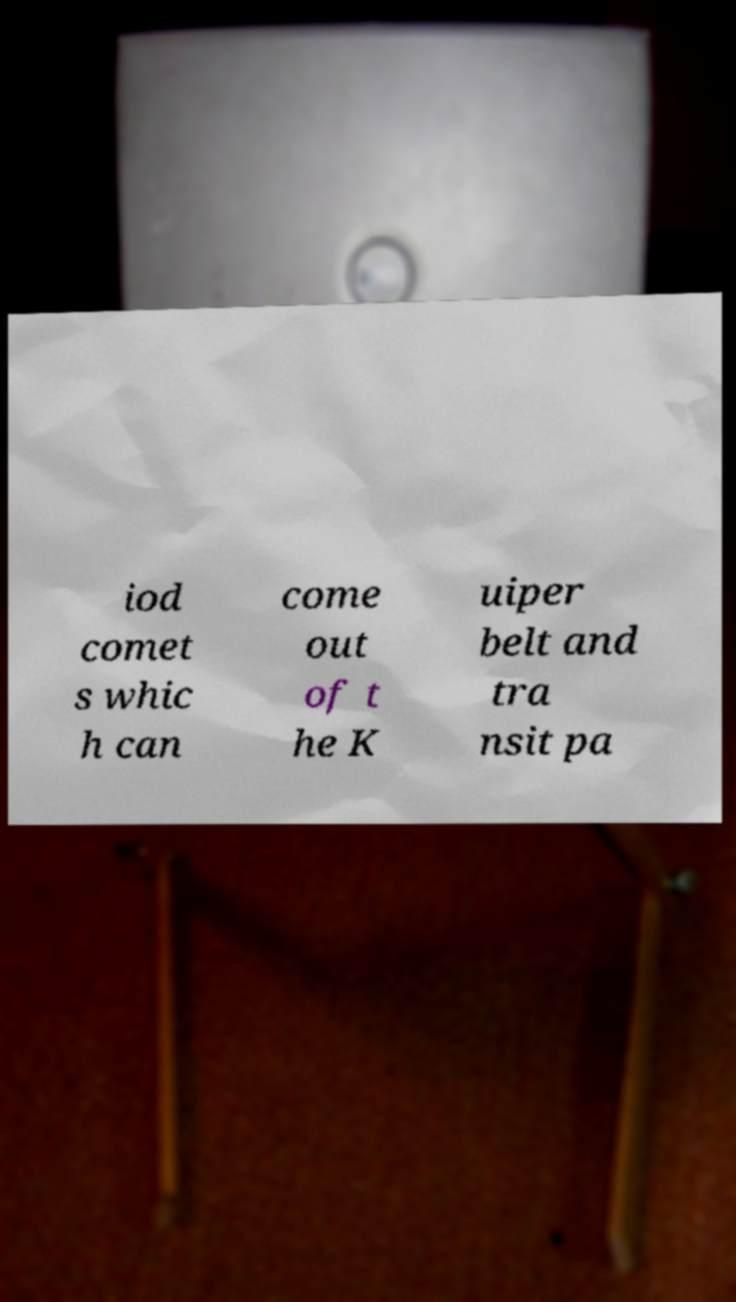I need the written content from this picture converted into text. Can you do that? iod comet s whic h can come out of t he K uiper belt and tra nsit pa 